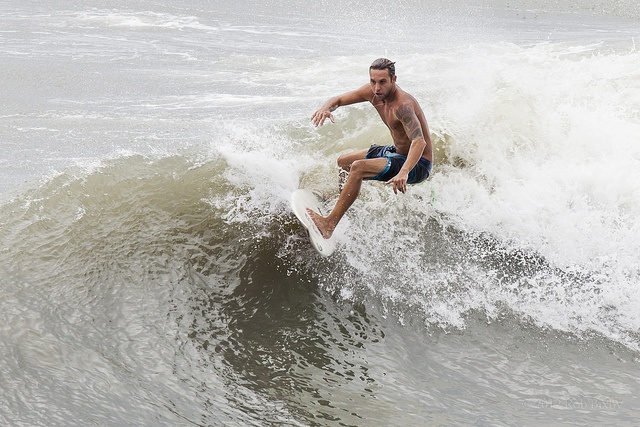Describe the objects in this image and their specific colors. I can see people in lightgray, brown, black, and maroon tones and surfboard in lightgray, darkgray, and gray tones in this image. 